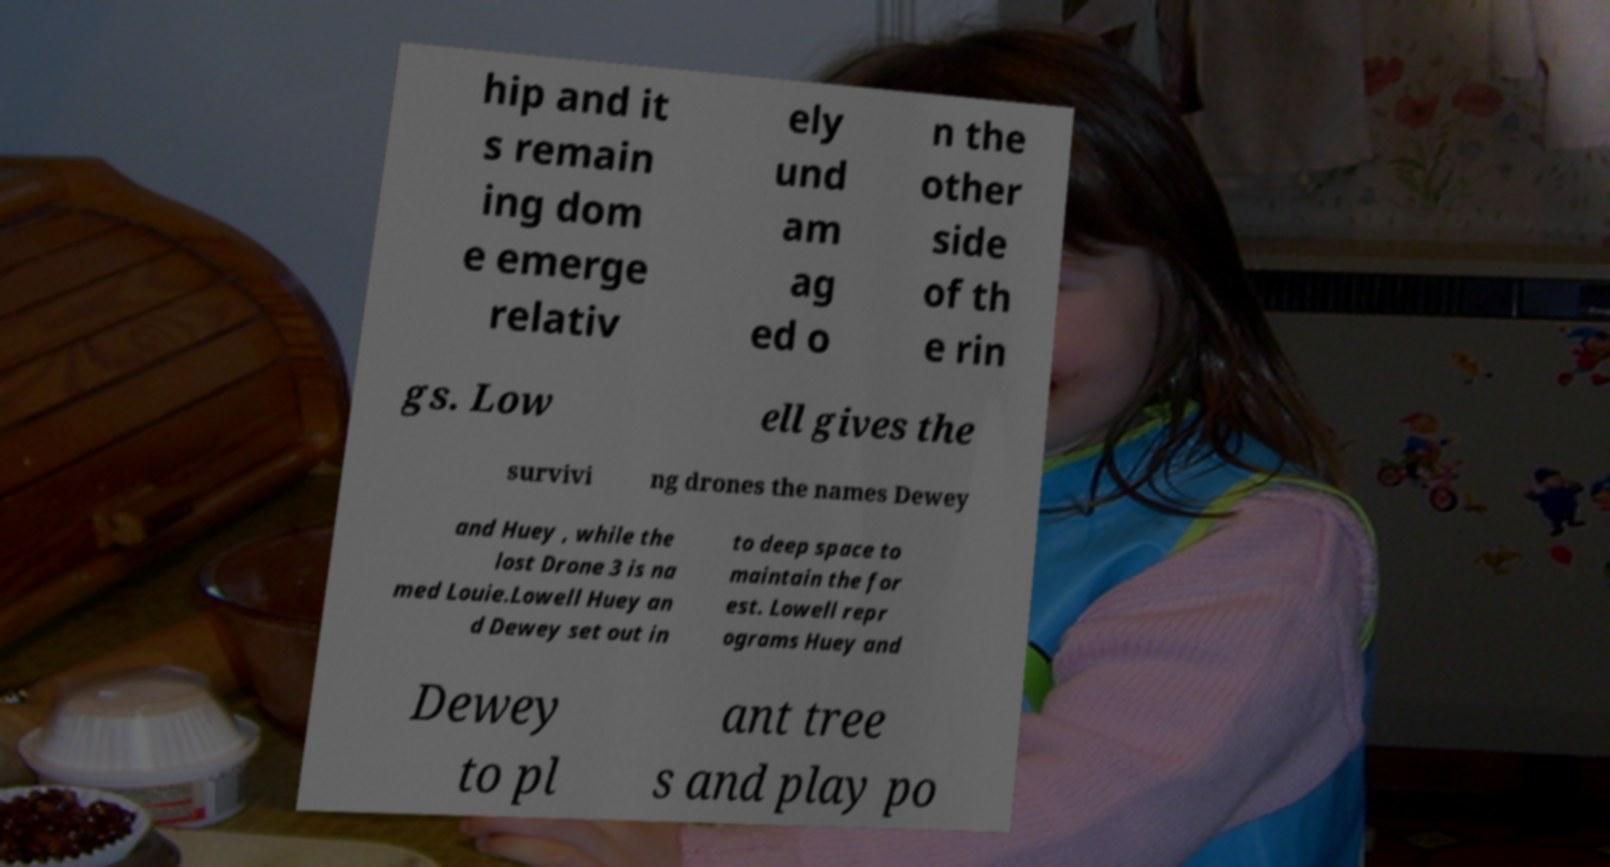There's text embedded in this image that I need extracted. Can you transcribe it verbatim? hip and it s remain ing dom e emerge relativ ely und am ag ed o n the other side of th e rin gs. Low ell gives the survivi ng drones the names Dewey and Huey , while the lost Drone 3 is na med Louie.Lowell Huey an d Dewey set out in to deep space to maintain the for est. Lowell repr ograms Huey and Dewey to pl ant tree s and play po 